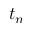<formula> <loc_0><loc_0><loc_500><loc_500>t _ { n }</formula> 